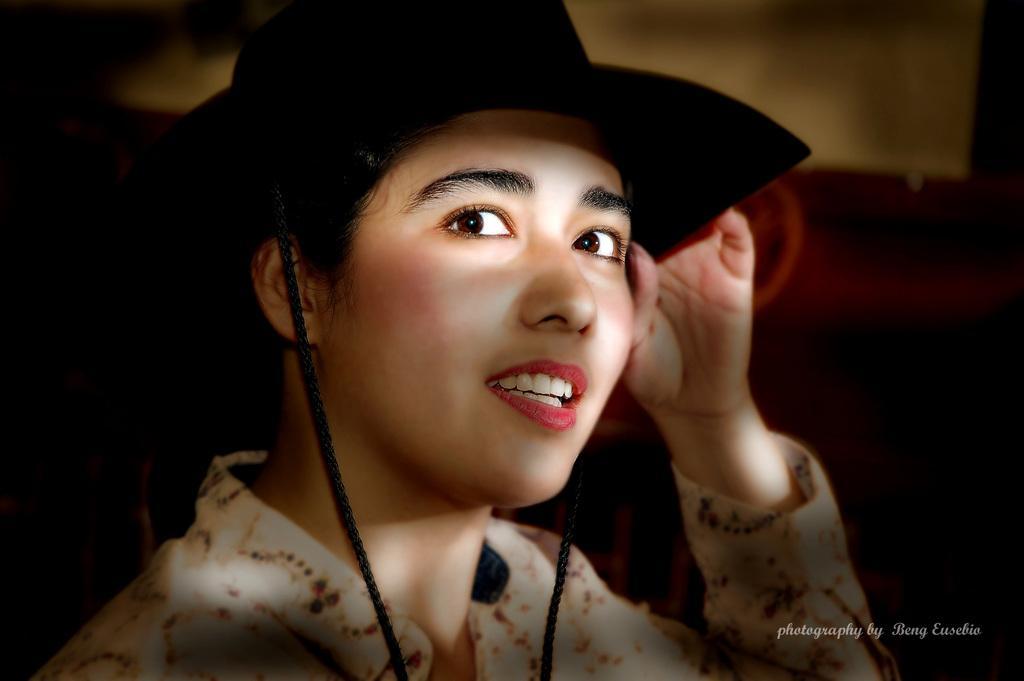Please provide a concise description of this image. In this image we can see a woman wearing the hat. In the bottom right corner we can see the text. 